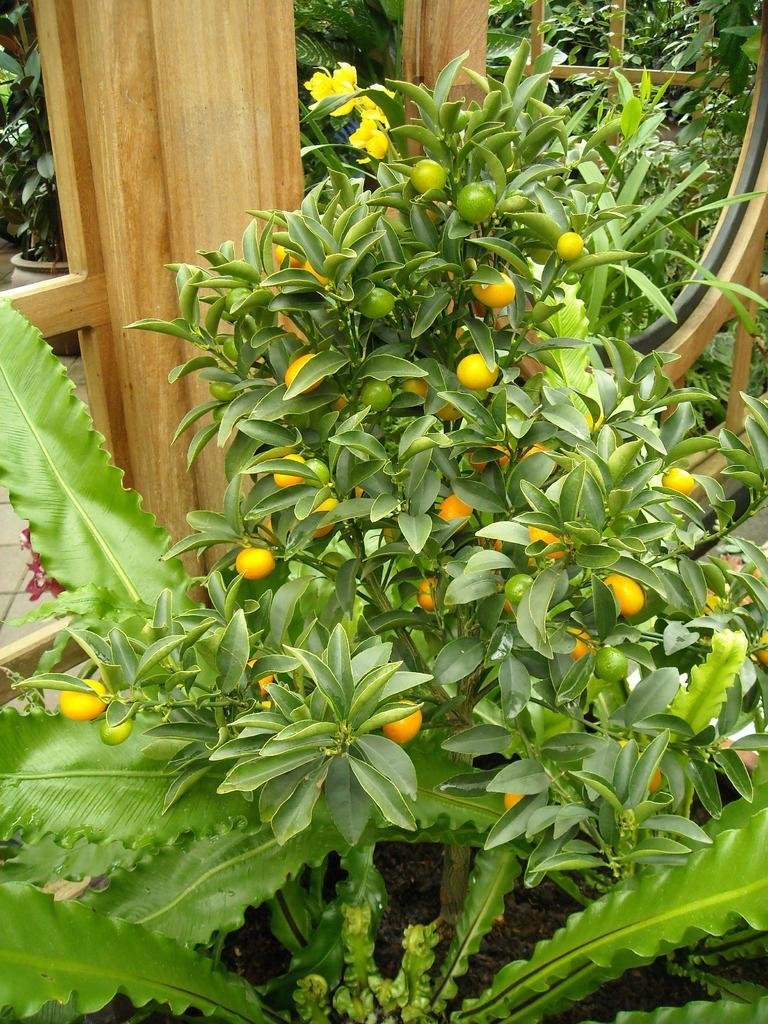What type of living organisms can be seen in the image? Plants are visible in the image. What colors and types of fruits are present in the image? There are orange and green color fruits in the center of the image. What material can be seen in the background of the image? Wooden things are visible in the background of the image. What type of education can be seen in the image? There is no reference to education in the image; it features plants and fruits. How many mice are visible in the image? There are no mice present in the image. 